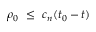Convert formula to latex. <formula><loc_0><loc_0><loc_500><loc_500>\rho _ { 0 } \leq c _ { n } ( t _ { 0 } - t )</formula> 